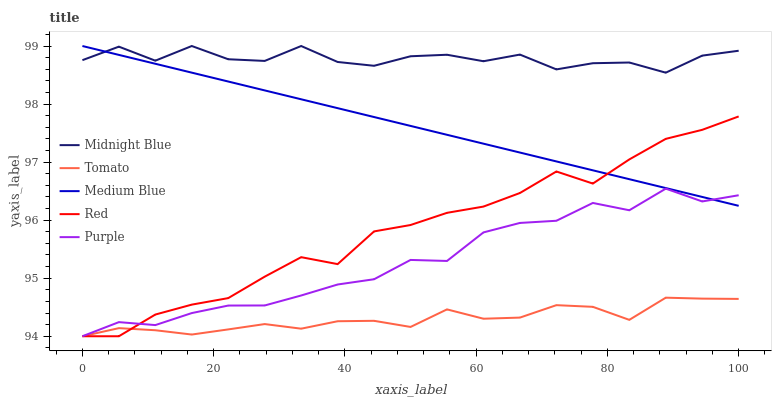Does Tomato have the minimum area under the curve?
Answer yes or no. Yes. Does Midnight Blue have the maximum area under the curve?
Answer yes or no. Yes. Does Purple have the minimum area under the curve?
Answer yes or no. No. Does Purple have the maximum area under the curve?
Answer yes or no. No. Is Medium Blue the smoothest?
Answer yes or no. Yes. Is Midnight Blue the roughest?
Answer yes or no. Yes. Is Purple the smoothest?
Answer yes or no. No. Is Purple the roughest?
Answer yes or no. No. Does Tomato have the lowest value?
Answer yes or no. Yes. Does Medium Blue have the lowest value?
Answer yes or no. No. Does Midnight Blue have the highest value?
Answer yes or no. Yes. Does Purple have the highest value?
Answer yes or no. No. Is Purple less than Midnight Blue?
Answer yes or no. Yes. Is Midnight Blue greater than Tomato?
Answer yes or no. Yes. Does Purple intersect Tomato?
Answer yes or no. Yes. Is Purple less than Tomato?
Answer yes or no. No. Is Purple greater than Tomato?
Answer yes or no. No. Does Purple intersect Midnight Blue?
Answer yes or no. No. 